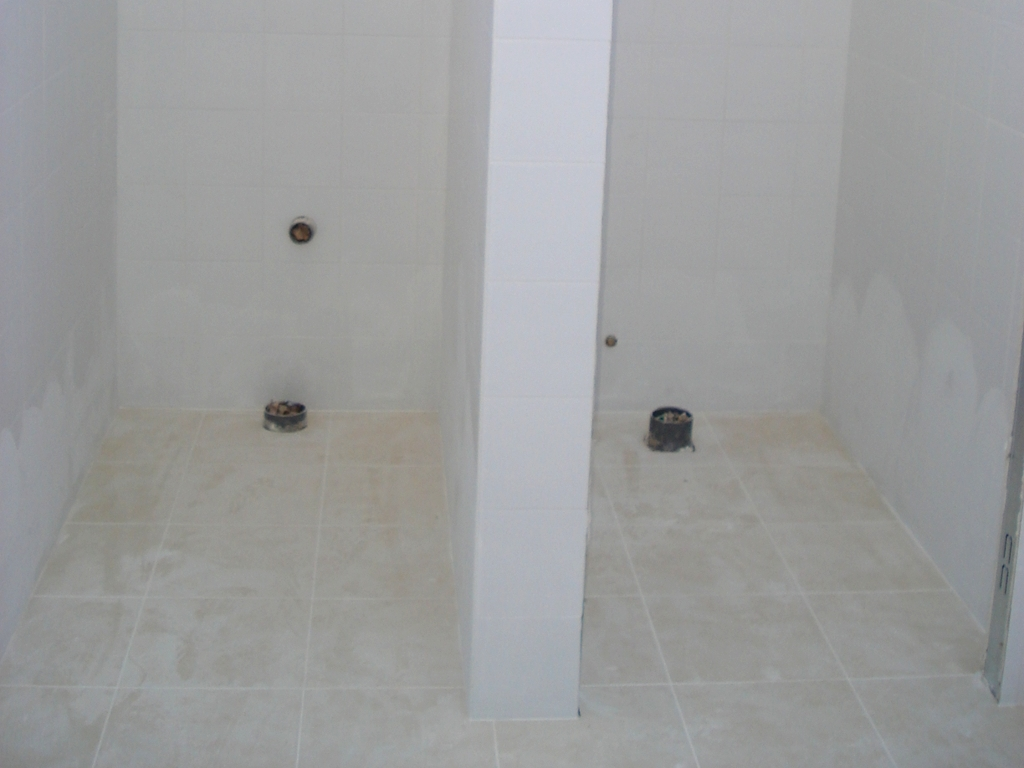Is the composition of this image quite good? While the composition of the image adheres to a simple and uncluttered aesthetic, it lacks dynamic interest or a clear subject that draws the viewer's attention. Composition in photography is largely subjective, but generally, a 'quite good' composition would feature a balance of elements, focal points, and perhaps follow certain guidelines like the rule of thirds, leading lines, or framing. Here, the elements are somewhat balanced with a symmetrical division due to the central column, but the absence of a distinct subject or an engaging perspective results in a composition that might be considered lacking in artistic intent or visual appeal. 